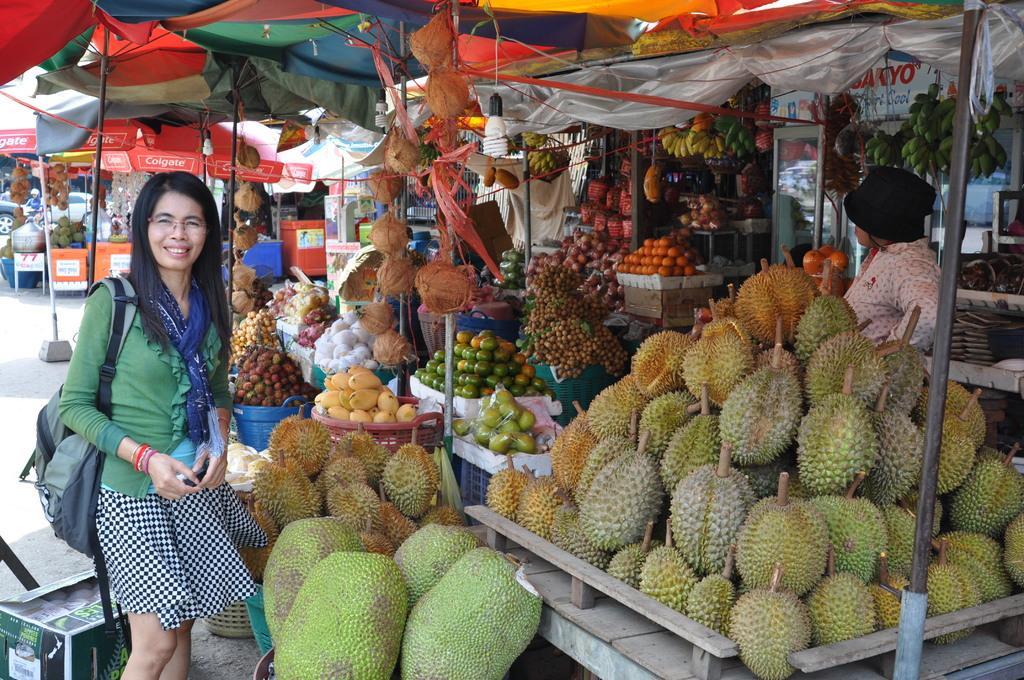Please provide a concise description of this image. In front of the image there is a woman with a smile on her face is standing in front of a fruit stall with different kinds of fruits. In the stall there is a vendor. Behind the woman there is a box and there are other stalls. At the top of the image there are tents supported by metal rods. In the background of the image there are cars.  